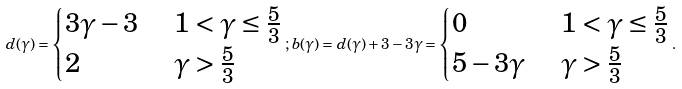Convert formula to latex. <formula><loc_0><loc_0><loc_500><loc_500>d ( \gamma ) = \begin{cases} 3 \gamma - 3 & \ 1 < \gamma \leq \frac { 5 } { 3 } \\ 2 & \ \gamma > \frac { 5 } { 3 } \end{cases} ; b ( \gamma ) = d ( \gamma ) + 3 - 3 \gamma = \begin{cases} 0 & \ 1 < \gamma \leq \frac { 5 } { 3 } \\ 5 - 3 \gamma & \ \gamma > \frac { 5 } { 3 } \end{cases} .</formula> 